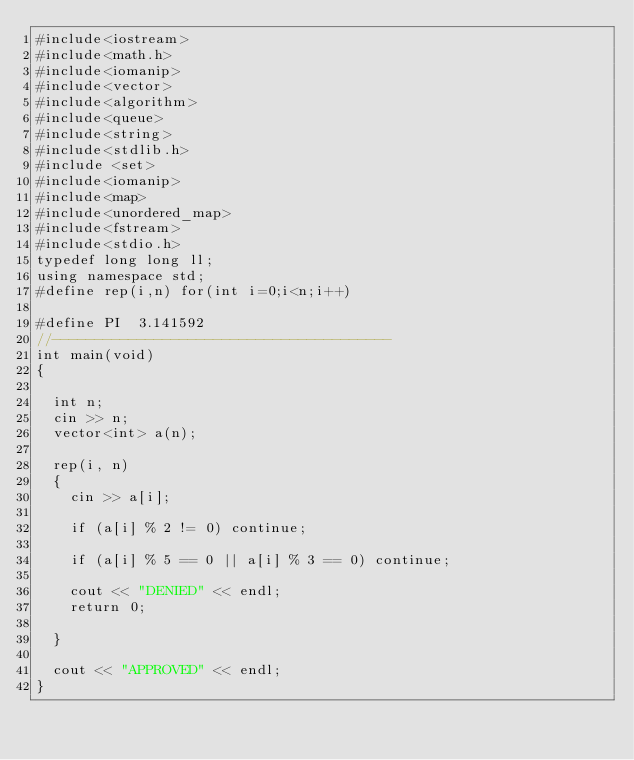Convert code to text. <code><loc_0><loc_0><loc_500><loc_500><_C++_>#include<iostream>
#include<math.h>
#include<iomanip>
#include<vector>
#include<algorithm>
#include<queue>
#include<string>
#include<stdlib.h>
#include <set>
#include<iomanip>
#include<map>
#include<unordered_map>
#include<fstream>
#include<stdio.h>
typedef long long ll;
using namespace std;
#define rep(i,n) for(int i=0;i<n;i++)

#define PI  3.141592
//----------------------------------------
int main(void)
{

	int n;
	cin >> n;
	vector<int> a(n);

	rep(i, n)
	{
		cin >> a[i];

		if (a[i] % 2 != 0) continue;

		if (a[i] % 5 == 0 || a[i] % 3 == 0) continue;

		cout << "DENIED" << endl;
		return 0;

	}

	cout << "APPROVED" << endl;
}</code> 